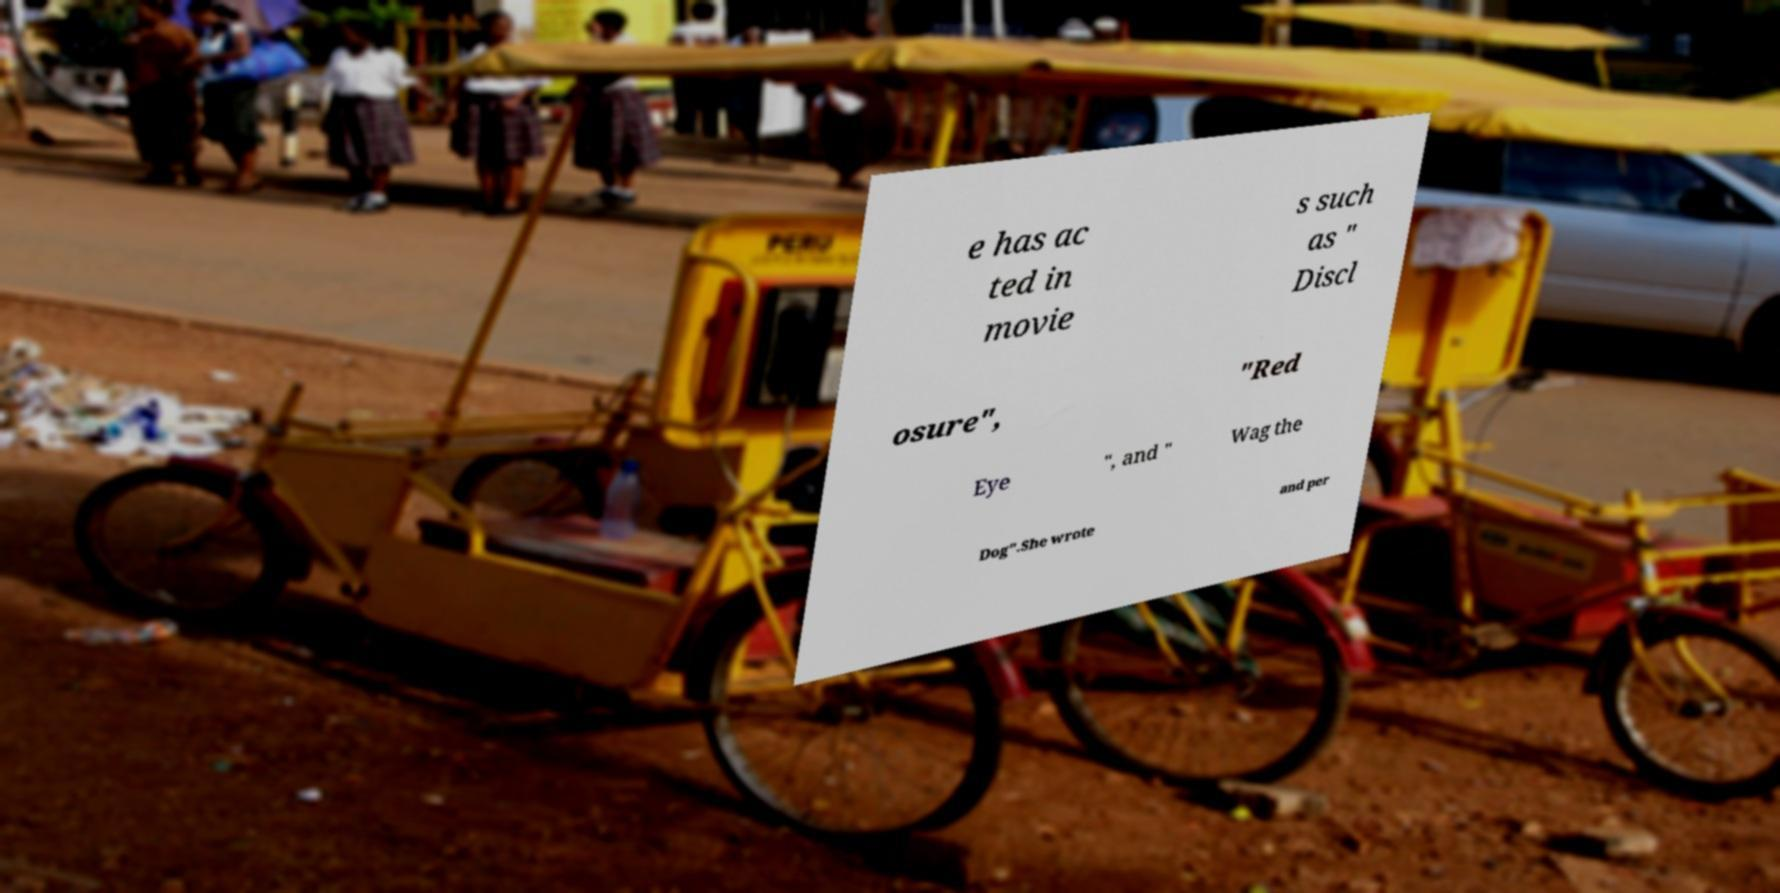I need the written content from this picture converted into text. Can you do that? e has ac ted in movie s such as " Discl osure", "Red Eye ", and " Wag the Dog".She wrote and per 